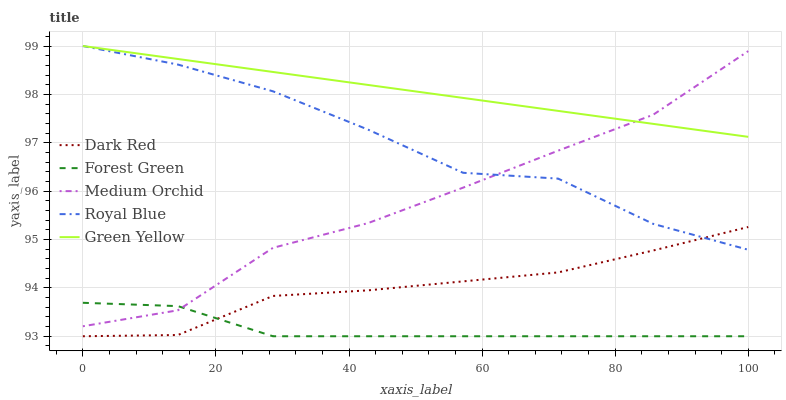Does Medium Orchid have the minimum area under the curve?
Answer yes or no. No. Does Medium Orchid have the maximum area under the curve?
Answer yes or no. No. Is Forest Green the smoothest?
Answer yes or no. No. Is Forest Green the roughest?
Answer yes or no. No. Does Medium Orchid have the lowest value?
Answer yes or no. No. Does Medium Orchid have the highest value?
Answer yes or no. No. Is Dark Red less than Green Yellow?
Answer yes or no. Yes. Is Green Yellow greater than Dark Red?
Answer yes or no. Yes. Does Dark Red intersect Green Yellow?
Answer yes or no. No. 